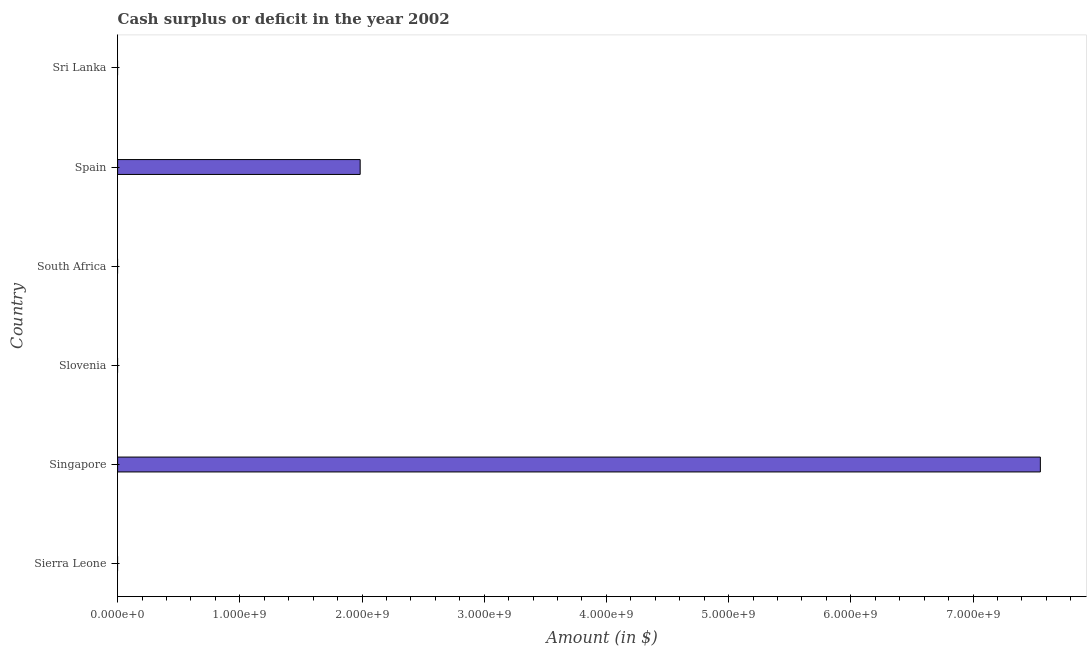Does the graph contain any zero values?
Keep it short and to the point. Yes. What is the title of the graph?
Your response must be concise. Cash surplus or deficit in the year 2002. What is the label or title of the X-axis?
Provide a short and direct response. Amount (in $). What is the cash surplus or deficit in Singapore?
Provide a short and direct response. 7.55e+09. Across all countries, what is the maximum cash surplus or deficit?
Offer a terse response. 7.55e+09. In which country was the cash surplus or deficit maximum?
Offer a terse response. Singapore. What is the sum of the cash surplus or deficit?
Your answer should be compact. 9.54e+09. What is the difference between the cash surplus or deficit in Singapore and Spain?
Keep it short and to the point. 5.57e+09. What is the average cash surplus or deficit per country?
Make the answer very short. 1.59e+09. What is the median cash surplus or deficit?
Provide a succinct answer. 0. Is the difference between the cash surplus or deficit in Singapore and Spain greater than the difference between any two countries?
Provide a short and direct response. No. What is the difference between the highest and the lowest cash surplus or deficit?
Give a very brief answer. 7.55e+09. How many bars are there?
Your response must be concise. 2. Are all the bars in the graph horizontal?
Offer a terse response. Yes. What is the Amount (in $) in Sierra Leone?
Make the answer very short. 0. What is the Amount (in $) of Singapore?
Your response must be concise. 7.55e+09. What is the Amount (in $) of Spain?
Make the answer very short. 1.98e+09. What is the Amount (in $) in Sri Lanka?
Offer a very short reply. 0. What is the difference between the Amount (in $) in Singapore and Spain?
Provide a short and direct response. 5.57e+09. What is the ratio of the Amount (in $) in Singapore to that in Spain?
Your answer should be compact. 3.8. 